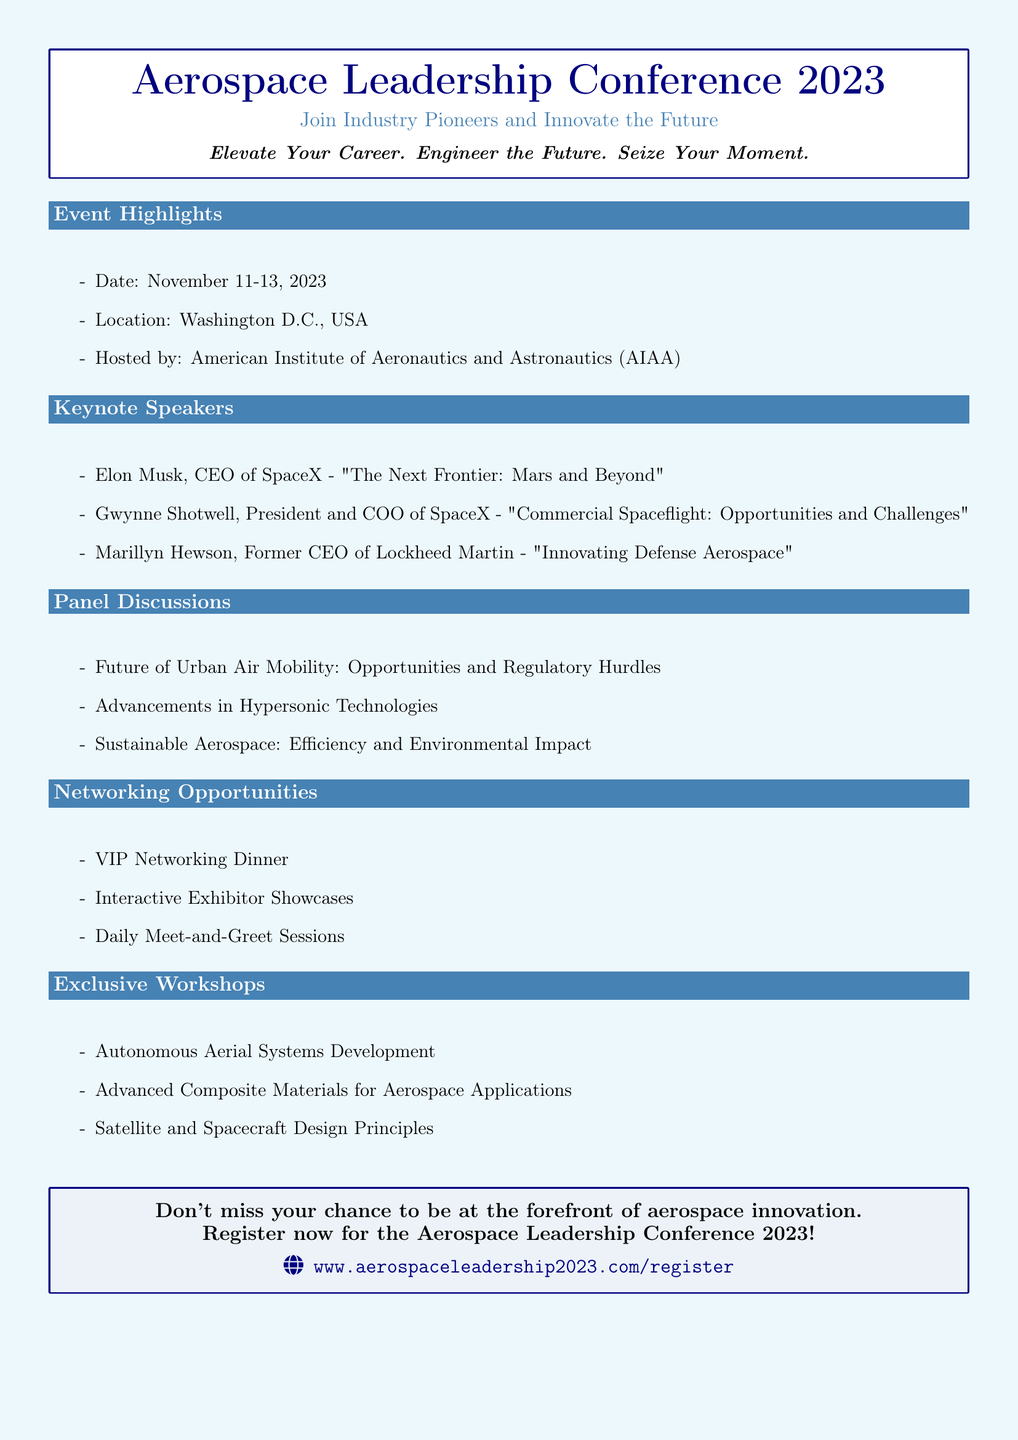What are the dates of the conference? The document lists the event dates as November 11-13, 2023.
Answer: November 11-13, 2023 Who is the host organization of the conference? The document identifies the host organization as the American Institute of Aeronautics and Astronautics (AIAA).
Answer: American Institute of Aeronautics and Astronautics (AIAA) What is the location of the conference? The location specified in the document is Washington D.C., USA.
Answer: Washington D.C., USA Who is speaking about "The Next Frontier: Mars and Beyond"? The document mentions Elon Musk as the speaker for that topic.
Answer: Elon Musk What is one of the panel discussion topics listed in the document? The document includes "Sustainable Aerospace: Efficiency and Environmental Impact" as one of the topics.
Answer: Sustainable Aerospace: Efficiency and Environmental Impact What exclusive workshop focuses on design principles? The document states that "Satellite and Spacecraft Design Principles" is one of the workshops.
Answer: Satellite and Spacecraft Design Principles How many keynote speakers are mentioned in the document? The document lists three keynote speakers.
Answer: Three What type of networking opportunity is provided for VIPs? The document refers to a VIP Networking Dinner as one of the opportunities.
Answer: VIP Networking Dinner What is the focus of the conference according to the tagline? The tagline emphasizes the conference's focus on innovation in aerospace and career elevation.
Answer: Innovate the Future 